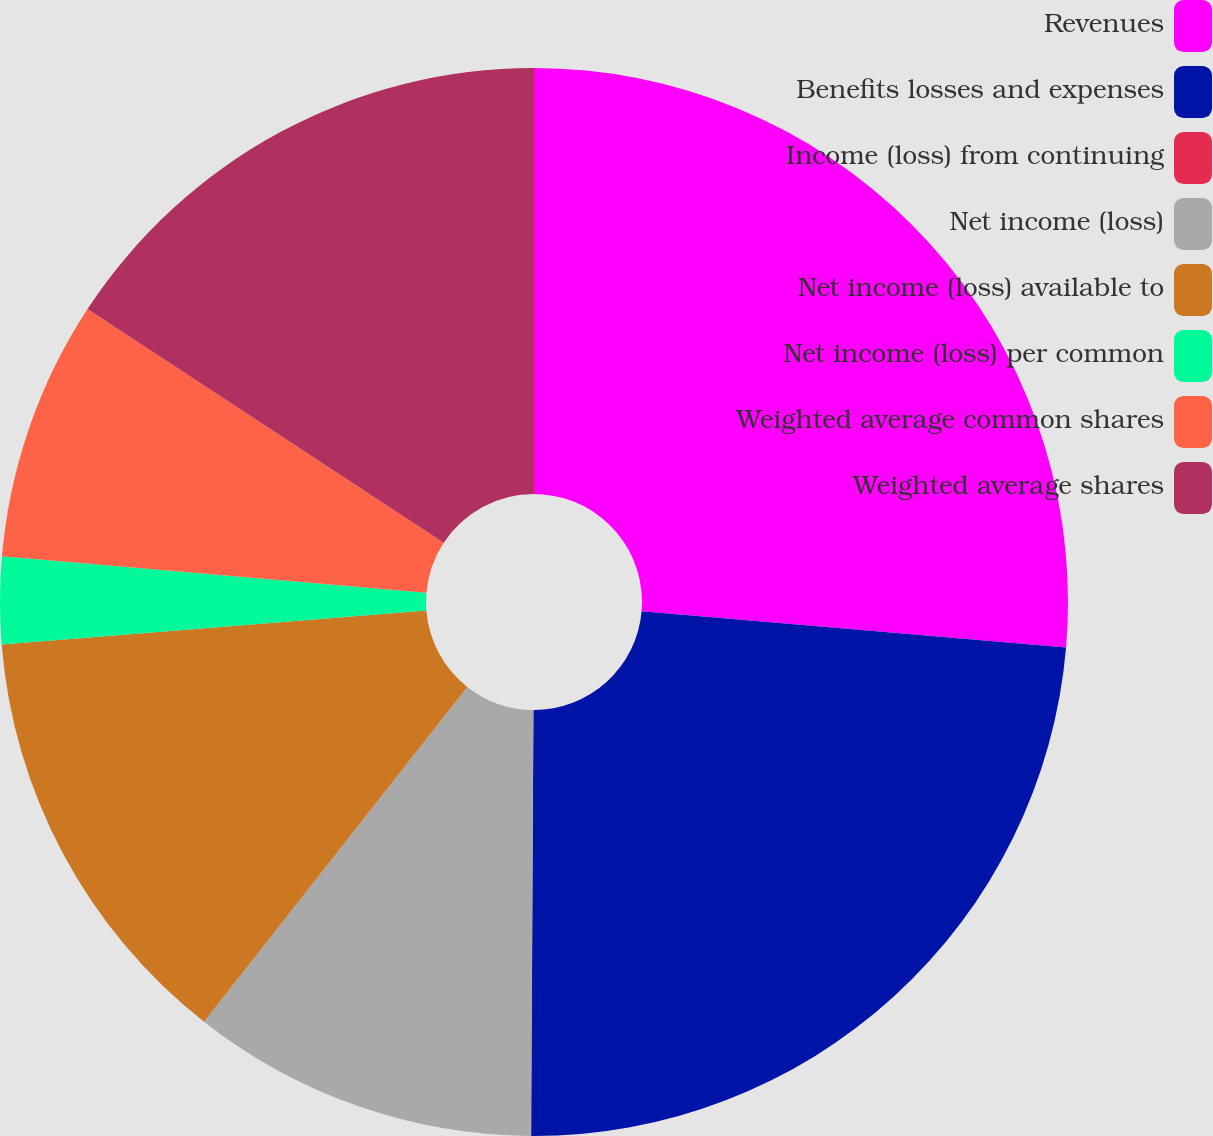Convert chart. <chart><loc_0><loc_0><loc_500><loc_500><pie_chart><fcel>Revenues<fcel>Benefits losses and expenses<fcel>Income (loss) from continuing<fcel>Net income (loss)<fcel>Net income (loss) available to<fcel>Net income (loss) per common<fcel>Weighted average common shares<fcel>Weighted average shares<nl><fcel>26.36%<fcel>23.73%<fcel>0.01%<fcel>10.51%<fcel>13.13%<fcel>2.63%<fcel>7.88%<fcel>15.76%<nl></chart> 